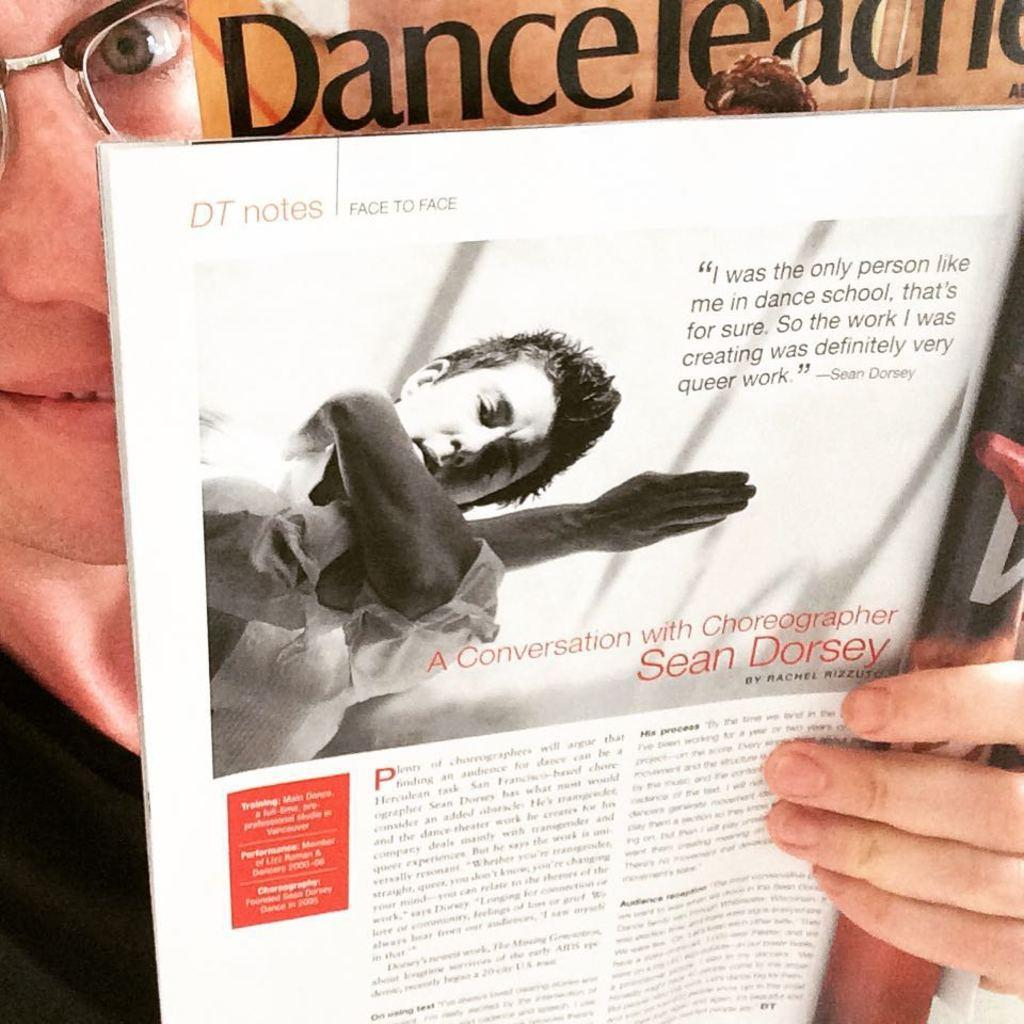<image>
Offer a succinct explanation of the picture presented. A man holding up a magazine page of Sean Dorsey. 